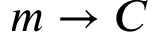<formula> <loc_0><loc_0><loc_500><loc_500>m \rightarrow C</formula> 